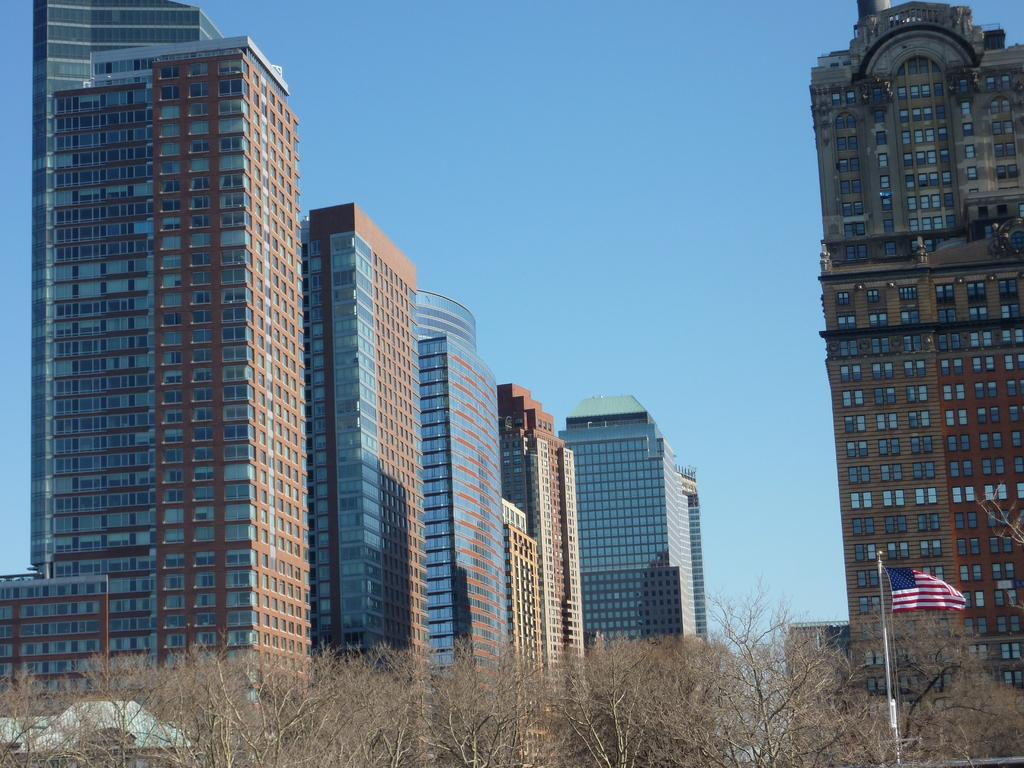What type of vegetation can be seen in the image? There are trees in the image. What is attached to the pole in the image? There is a flag on a pole in the image. What type of structures are visible in the image? There are tower buildings in the image. What color is the sky in the background of the image? The sky is blue in the background of the image. Are there any cherries or pizzas hanging from the trees in the image? There are no cherries or pizzas present in the image; the trees are not bearing fruit or food items. 